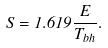Convert formula to latex. <formula><loc_0><loc_0><loc_500><loc_500>\dot { S } = 1 . 6 1 9 \frac { \dot { E } } { T _ { b h } } .</formula> 